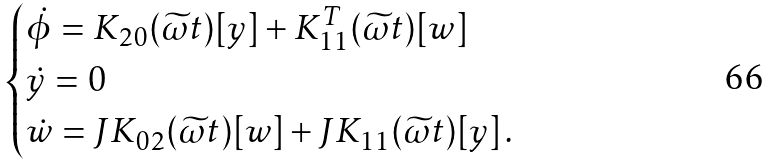Convert formula to latex. <formula><loc_0><loc_0><loc_500><loc_500>\begin{cases} \dot { \phi } = K _ { 2 0 } ( \widetilde { \omega } t ) [ y ] + K _ { 1 1 } ^ { T } ( \widetilde { \omega } t ) [ w ] \\ \dot { y } = 0 \\ \dot { w } = J K _ { 0 2 } ( \widetilde { \omega } t ) [ w ] + J K _ { 1 1 } ( \widetilde { \omega } t ) [ y ] \, . \end{cases}</formula> 